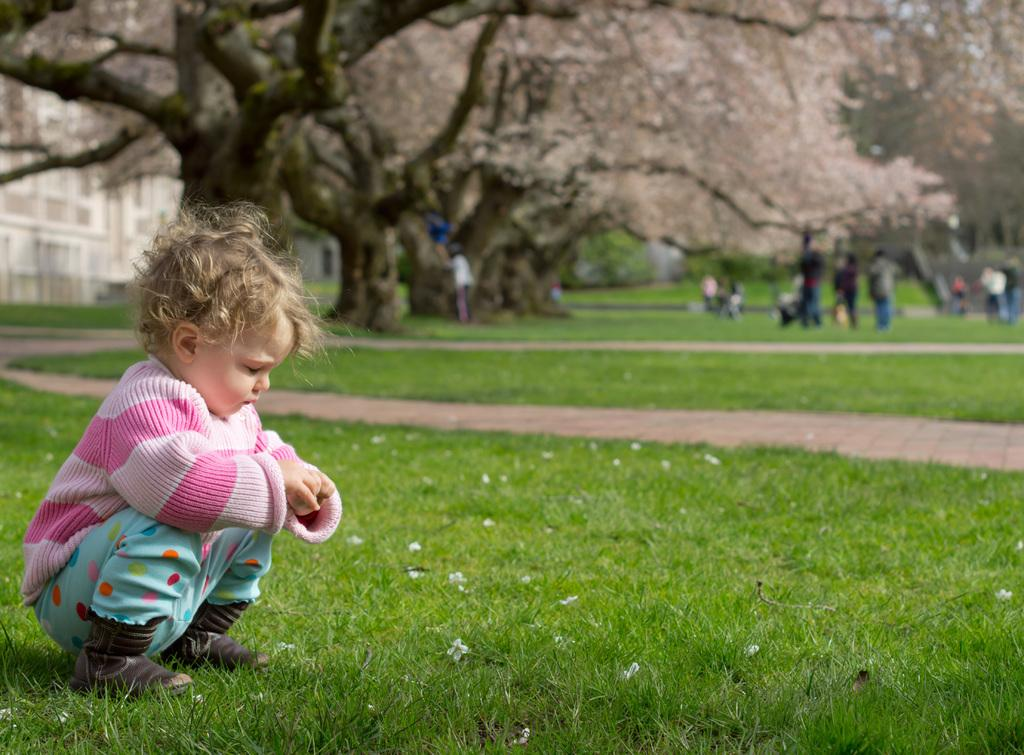What is the main subject in the foreground of the picture? There is a kid in the foreground of the picture. What is the kid doing in the picture? The kid is playing in the grass. What can be seen in the background of the picture? The background of the picture includes trees, people, grass, and a building. How many elements are present in the background of the picture? There are four elements present in the background: trees, people, grass, and a building. What is the natural setting visible in the picture? The natural setting includes grass and trees. What type of advertisement can be seen on the kid's shirt in the picture? There is no advertisement visible on the kid's shirt in the picture. What type of laborer is working in the background of the picture? There is no laborer present in the background of the picture. 